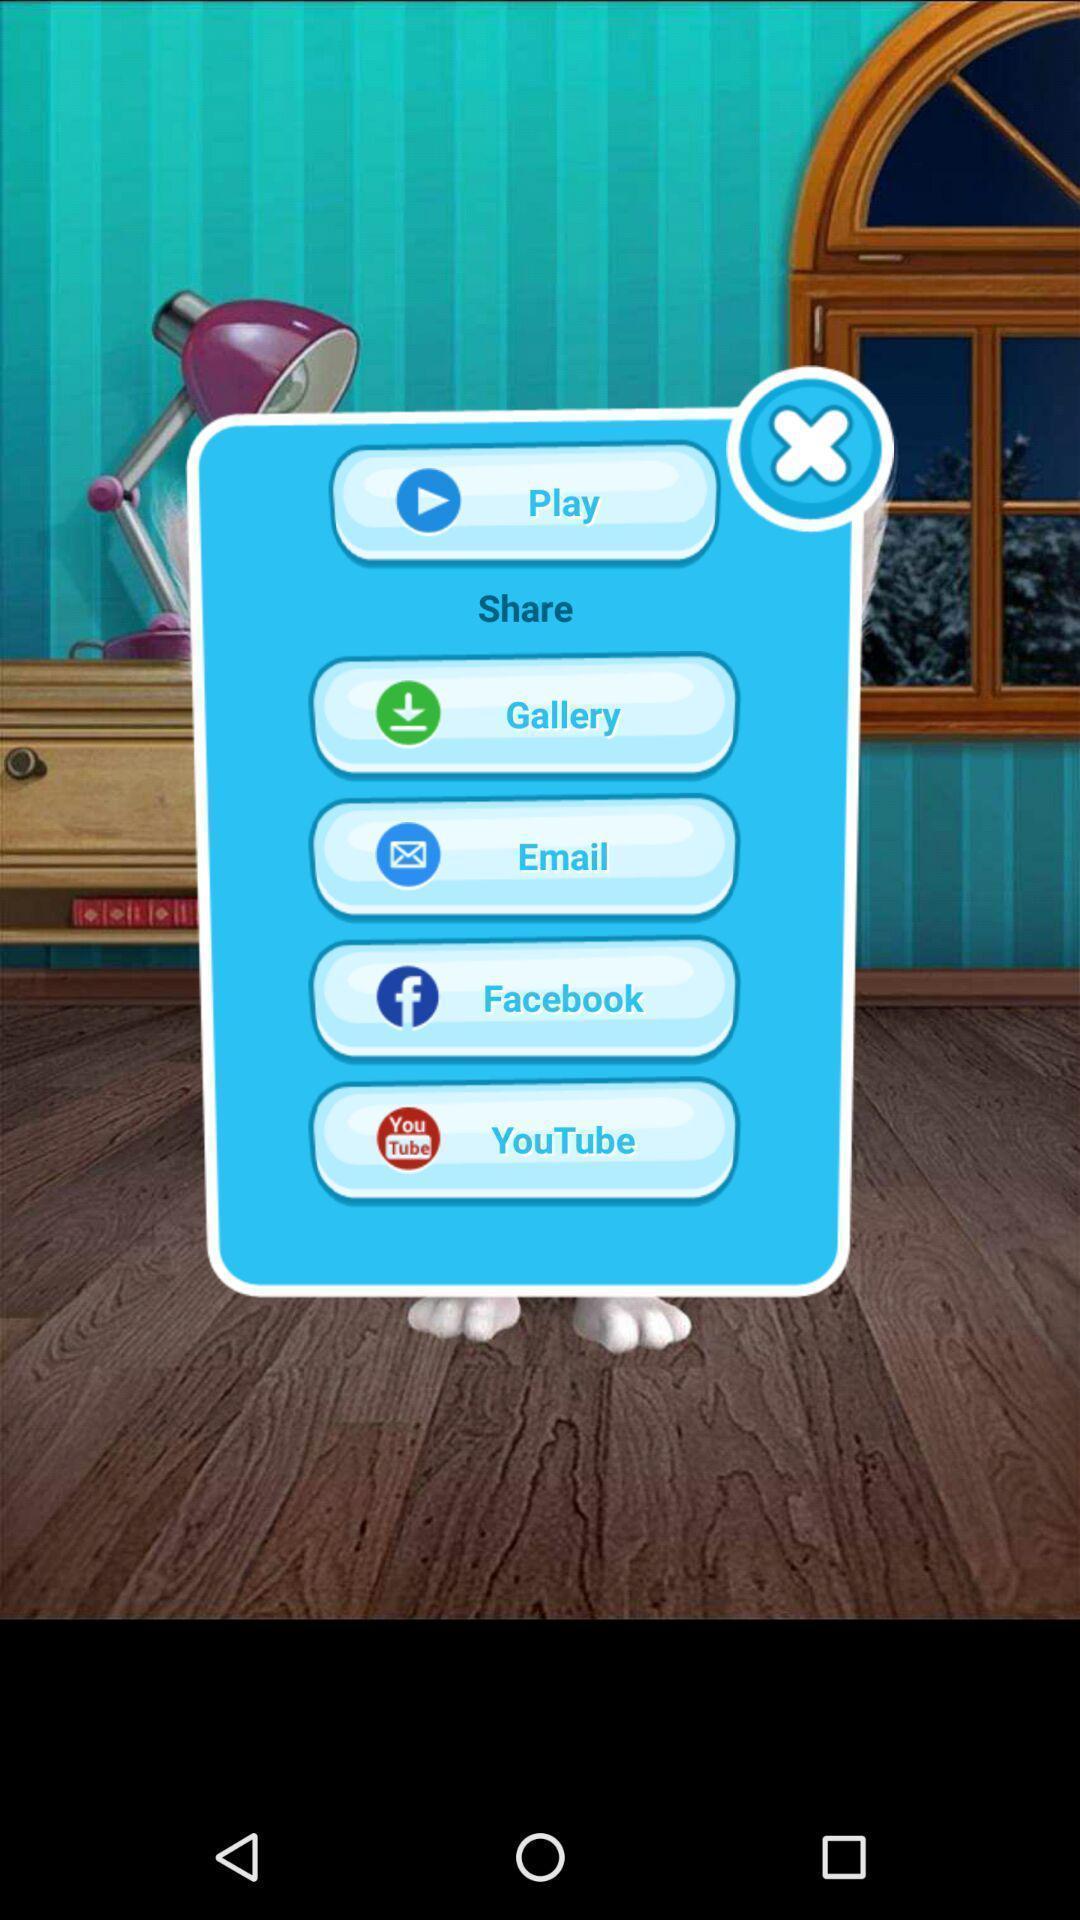Tell me about the visual elements in this screen capture. Pop-up shows different social apps. 